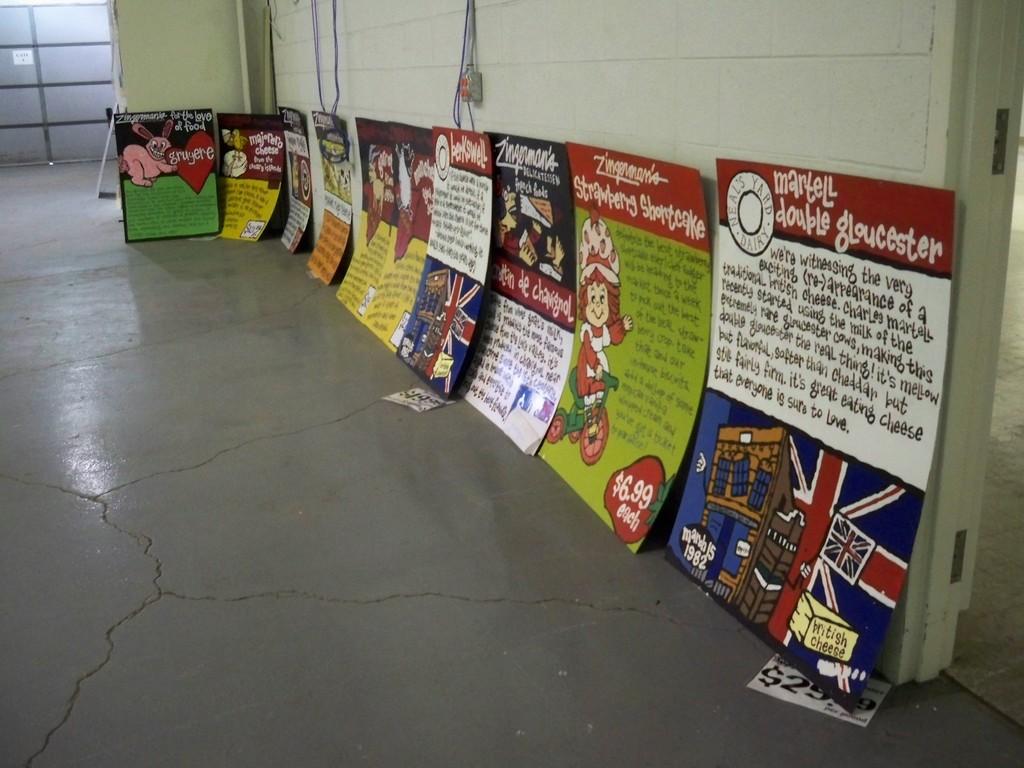What kind of cheese is mentioned in the poster on the bottom right?
Your answer should be very brief. British. 